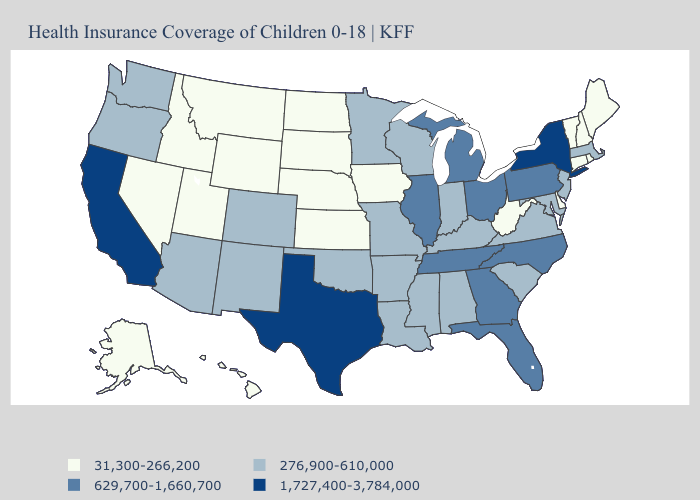Does New Mexico have the lowest value in the West?
Be succinct. No. Name the states that have a value in the range 31,300-266,200?
Answer briefly. Alaska, Connecticut, Delaware, Hawaii, Idaho, Iowa, Kansas, Maine, Montana, Nebraska, Nevada, New Hampshire, North Dakota, Rhode Island, South Dakota, Utah, Vermont, West Virginia, Wyoming. Among the states that border Missouri , which have the lowest value?
Answer briefly. Iowa, Kansas, Nebraska. What is the value of Minnesota?
Be succinct. 276,900-610,000. Name the states that have a value in the range 1,727,400-3,784,000?
Quick response, please. California, New York, Texas. Does North Carolina have the highest value in the USA?
Quick response, please. No. Does Nebraska have the lowest value in the USA?
Quick response, please. Yes. What is the lowest value in states that border North Dakota?
Quick response, please. 31,300-266,200. What is the value of West Virginia?
Quick response, please. 31,300-266,200. What is the value of New Jersey?
Quick response, please. 276,900-610,000. Name the states that have a value in the range 31,300-266,200?
Keep it brief. Alaska, Connecticut, Delaware, Hawaii, Idaho, Iowa, Kansas, Maine, Montana, Nebraska, Nevada, New Hampshire, North Dakota, Rhode Island, South Dakota, Utah, Vermont, West Virginia, Wyoming. What is the value of Wyoming?
Answer briefly. 31,300-266,200. What is the value of Florida?
Keep it brief. 629,700-1,660,700. 